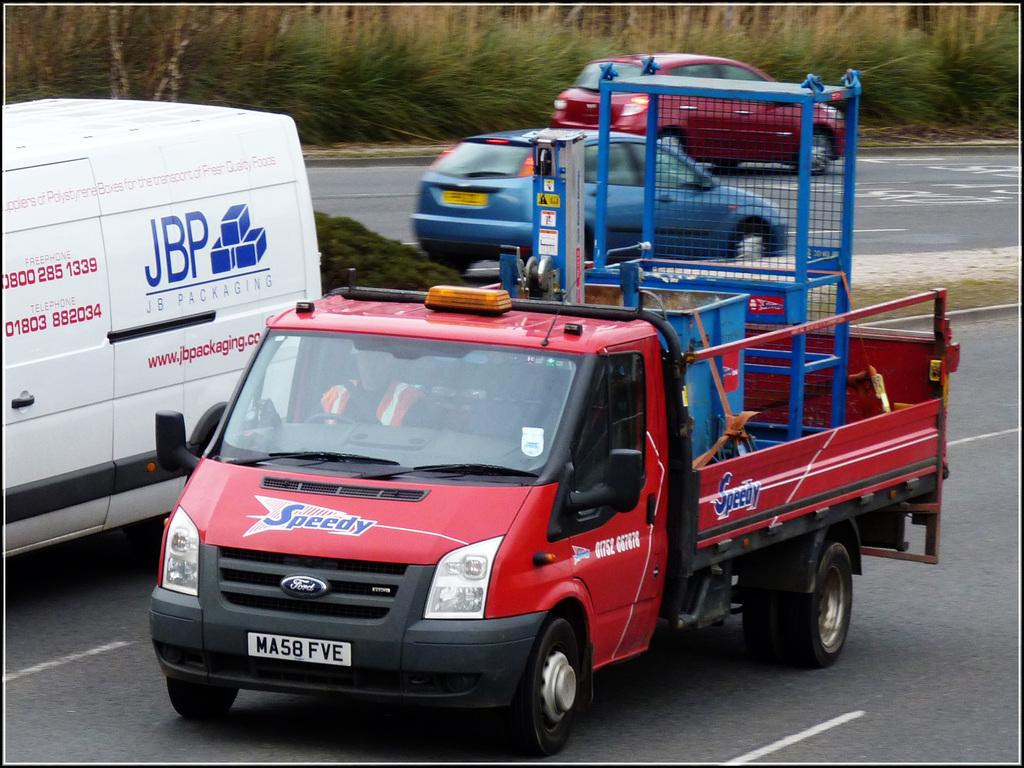What types of vehicles are in the foreground of the image? There is a white truck and a red truck in the foreground of the image. What is the red truck carrying? The red truck is carrying some loads. Can you describe the color of the white truck? The white truck is white. What type of floor can be seen in the image? There is no floor visible in the image; it features two trucks in the foreground. How does the grandfather interact with the trucks in the image? There is no grandfather present in the image, so it is not possible to determine how he might interact with the trucks. 